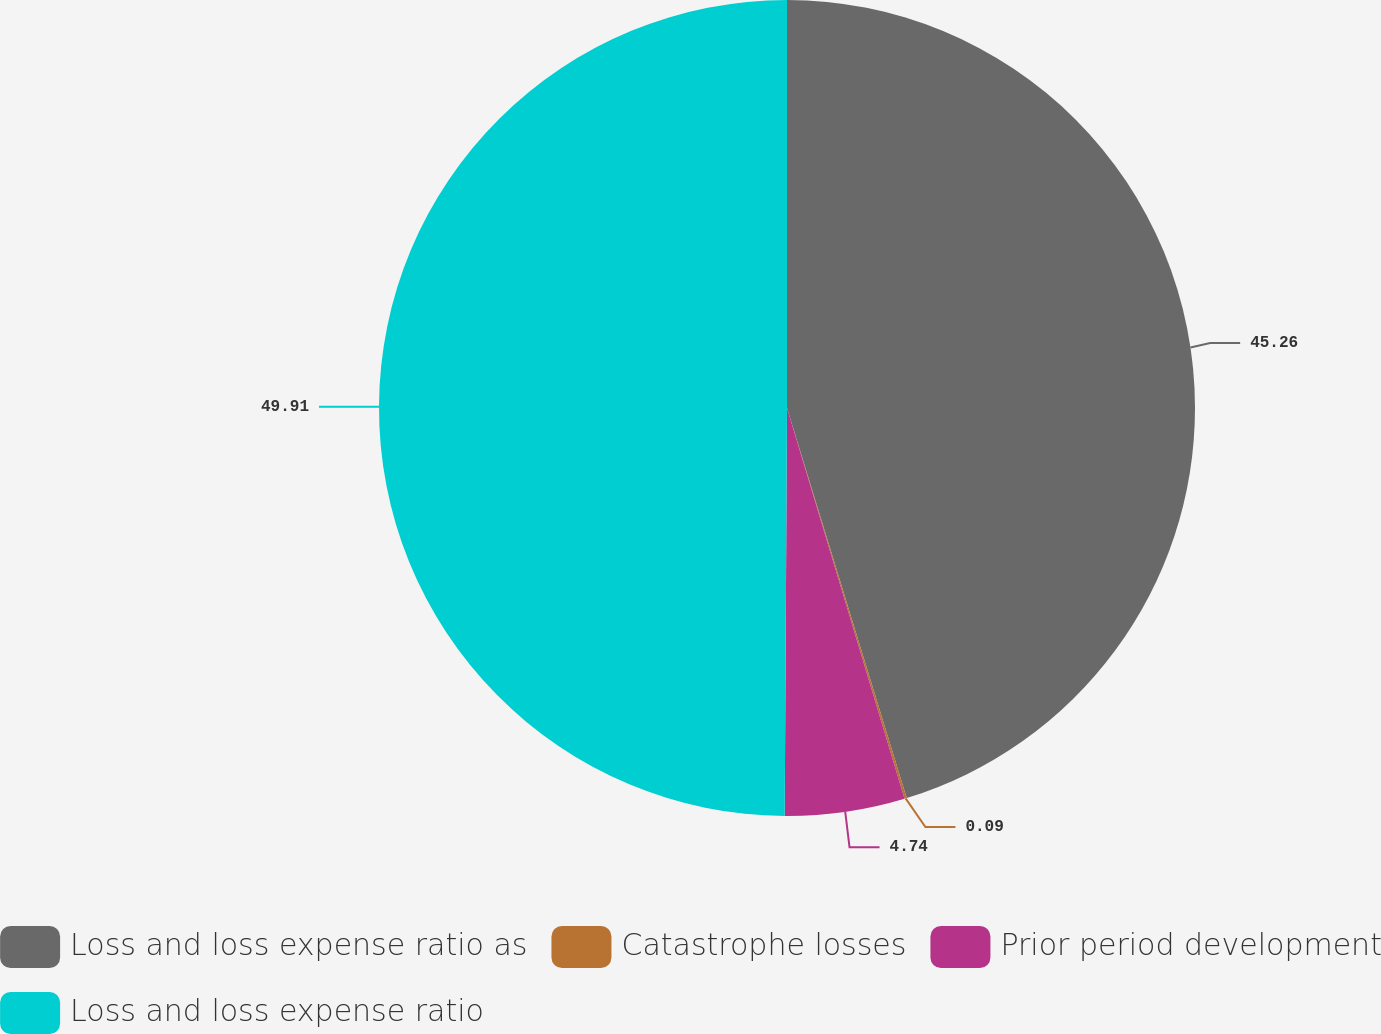Convert chart. <chart><loc_0><loc_0><loc_500><loc_500><pie_chart><fcel>Loss and loss expense ratio as<fcel>Catastrophe losses<fcel>Prior period development<fcel>Loss and loss expense ratio<nl><fcel>45.26%<fcel>0.09%<fcel>4.74%<fcel>49.91%<nl></chart> 